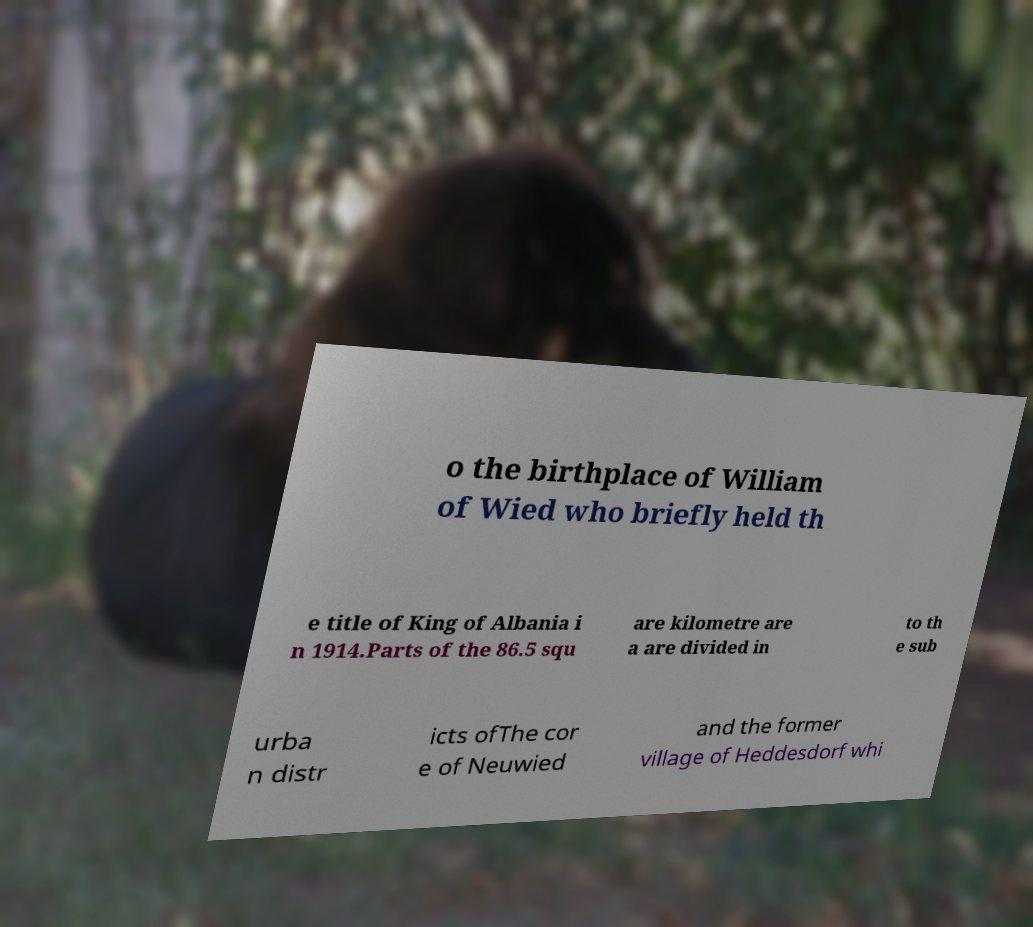What messages or text are displayed in this image? I need them in a readable, typed format. o the birthplace of William of Wied who briefly held th e title of King of Albania i n 1914.Parts of the 86.5 squ are kilometre are a are divided in to th e sub urba n distr icts ofThe cor e of Neuwied and the former village of Heddesdorf whi 